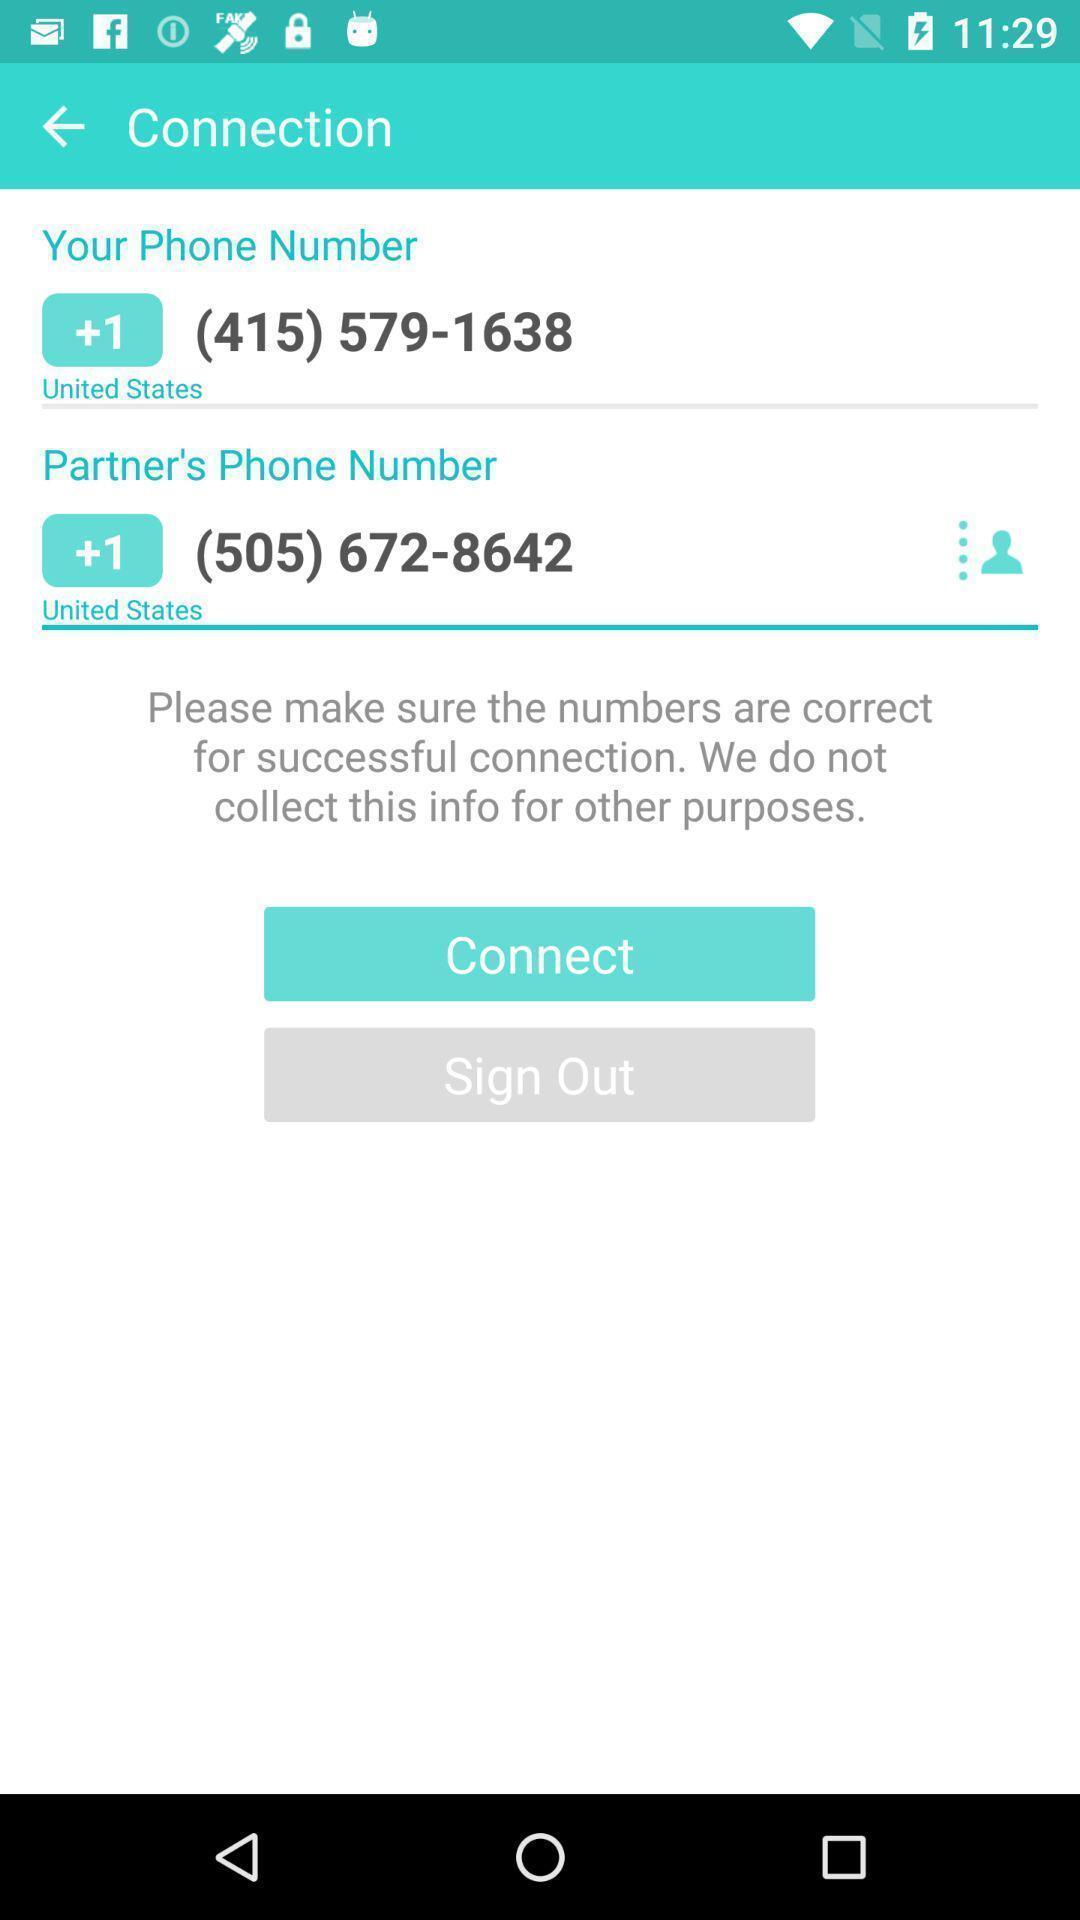What details can you identify in this image? Screen display sign out page. 